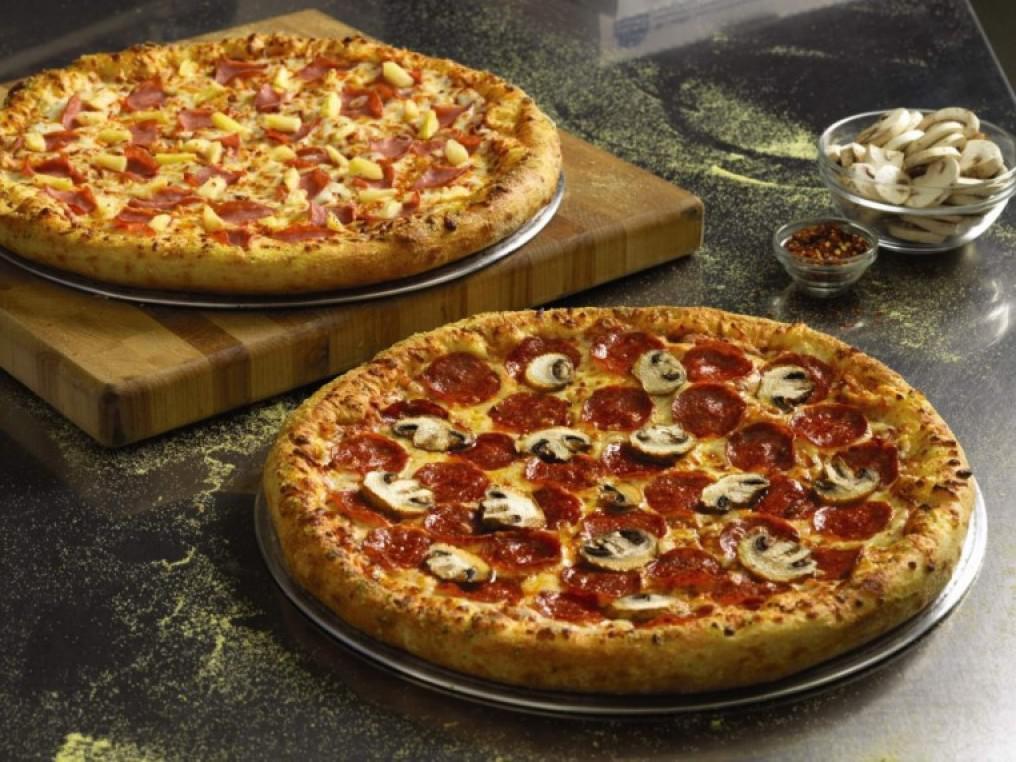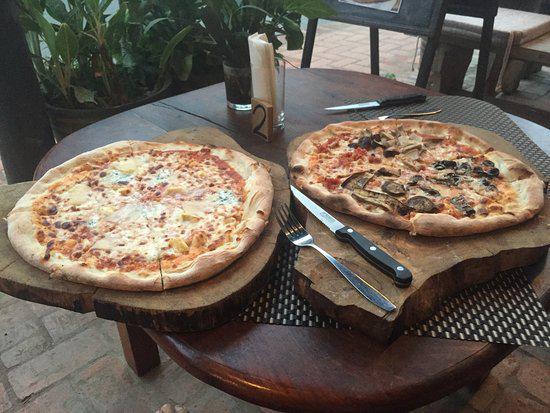The first image is the image on the left, the second image is the image on the right. For the images displayed, is the sentence "Each image contains two roundish pizzas with no slices missing." factually correct? Answer yes or no. Yes. The first image is the image on the left, the second image is the image on the right. For the images shown, is this caption "A fork and knife have been placed next to the pizza in one of the pictures." true? Answer yes or no. Yes. 